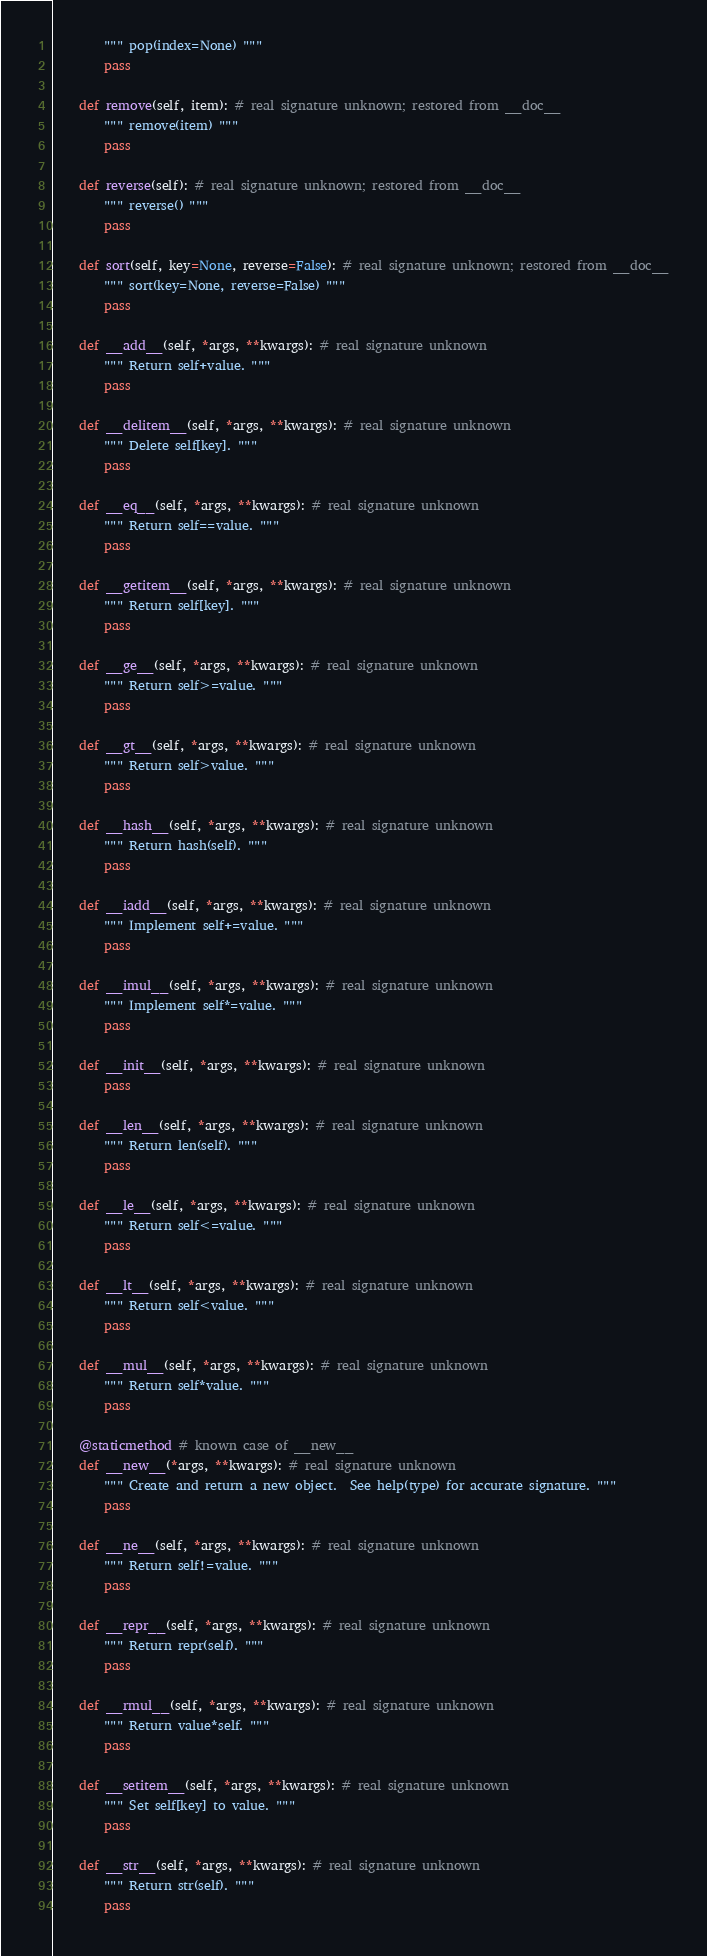Convert code to text. <code><loc_0><loc_0><loc_500><loc_500><_Python_>        """ pop(index=None) """
        pass

    def remove(self, item): # real signature unknown; restored from __doc__
        """ remove(item) """
        pass

    def reverse(self): # real signature unknown; restored from __doc__
        """ reverse() """
        pass

    def sort(self, key=None, reverse=False): # real signature unknown; restored from __doc__
        """ sort(key=None, reverse=False) """
        pass

    def __add__(self, *args, **kwargs): # real signature unknown
        """ Return self+value. """
        pass

    def __delitem__(self, *args, **kwargs): # real signature unknown
        """ Delete self[key]. """
        pass

    def __eq__(self, *args, **kwargs): # real signature unknown
        """ Return self==value. """
        pass

    def __getitem__(self, *args, **kwargs): # real signature unknown
        """ Return self[key]. """
        pass

    def __ge__(self, *args, **kwargs): # real signature unknown
        """ Return self>=value. """
        pass

    def __gt__(self, *args, **kwargs): # real signature unknown
        """ Return self>value. """
        pass

    def __hash__(self, *args, **kwargs): # real signature unknown
        """ Return hash(self). """
        pass

    def __iadd__(self, *args, **kwargs): # real signature unknown
        """ Implement self+=value. """
        pass

    def __imul__(self, *args, **kwargs): # real signature unknown
        """ Implement self*=value. """
        pass

    def __init__(self, *args, **kwargs): # real signature unknown
        pass

    def __len__(self, *args, **kwargs): # real signature unknown
        """ Return len(self). """
        pass

    def __le__(self, *args, **kwargs): # real signature unknown
        """ Return self<=value. """
        pass

    def __lt__(self, *args, **kwargs): # real signature unknown
        """ Return self<value. """
        pass

    def __mul__(self, *args, **kwargs): # real signature unknown
        """ Return self*value. """
        pass

    @staticmethod # known case of __new__
    def __new__(*args, **kwargs): # real signature unknown
        """ Create and return a new object.  See help(type) for accurate signature. """
        pass

    def __ne__(self, *args, **kwargs): # real signature unknown
        """ Return self!=value. """
        pass

    def __repr__(self, *args, **kwargs): # real signature unknown
        """ Return repr(self). """
        pass

    def __rmul__(self, *args, **kwargs): # real signature unknown
        """ Return value*self. """
        pass

    def __setitem__(self, *args, **kwargs): # real signature unknown
        """ Set self[key] to value. """
        pass

    def __str__(self, *args, **kwargs): # real signature unknown
        """ Return str(self). """
        pass
</code> 